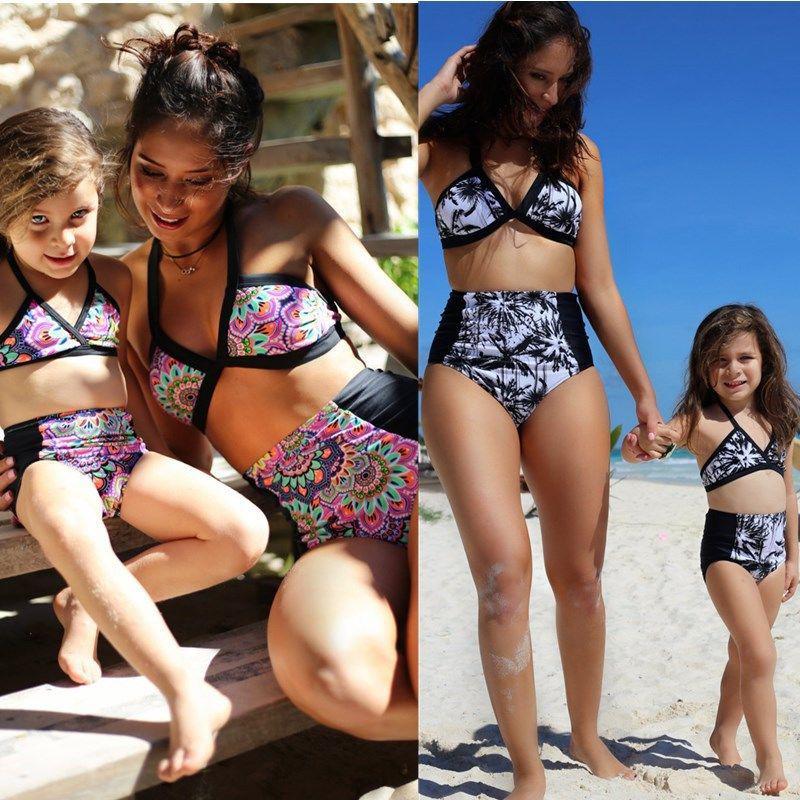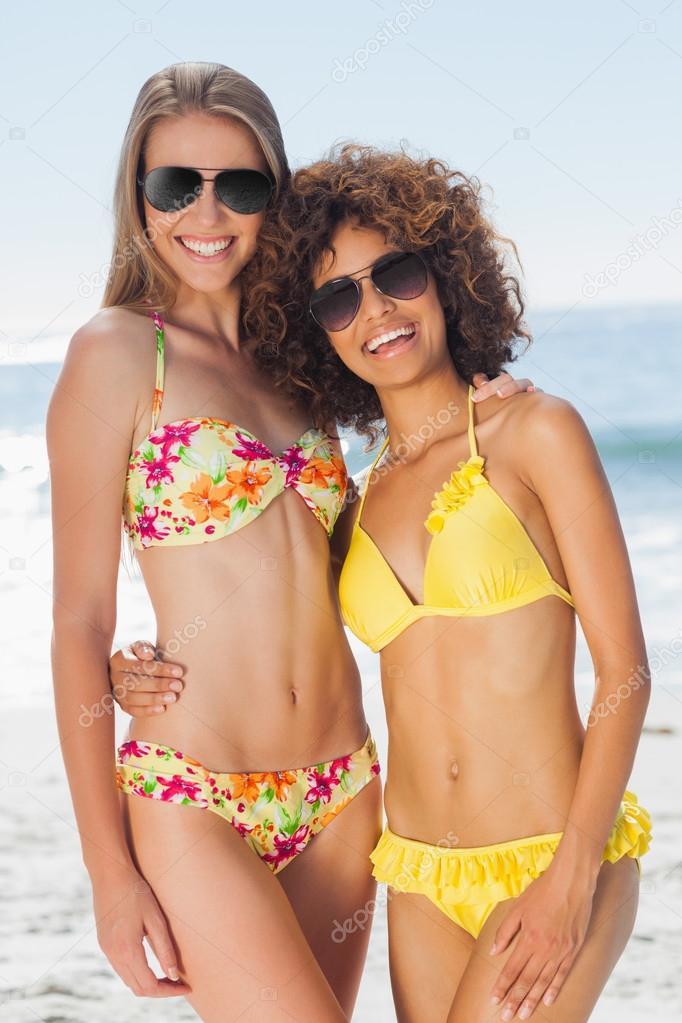The first image is the image on the left, the second image is the image on the right. Considering the images on both sides, is "At least one of the women in the image on the right is wearing sunglasses." valid? Answer yes or no. Yes. 